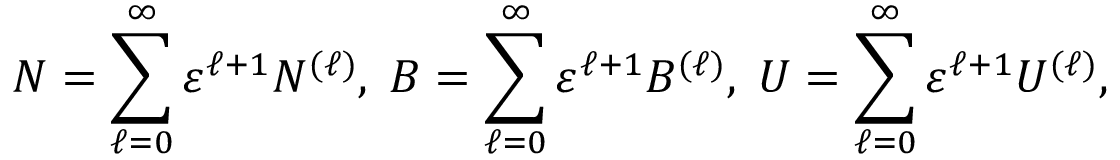Convert formula to latex. <formula><loc_0><loc_0><loc_500><loc_500>N = \sum _ { \ell = 0 } ^ { \infty } \varepsilon ^ { \ell + 1 } N ^ { ( \ell ) } , \, B = \sum _ { \ell = 0 } ^ { \infty } \varepsilon ^ { \ell + 1 } B ^ { ( \ell ) } , \, U = \sum _ { \ell = 0 } ^ { \infty } \varepsilon ^ { \ell + 1 } U ^ { ( \ell ) } ,</formula> 